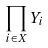<formula> <loc_0><loc_0><loc_500><loc_500>\prod _ { i \in X } Y _ { i }</formula> 